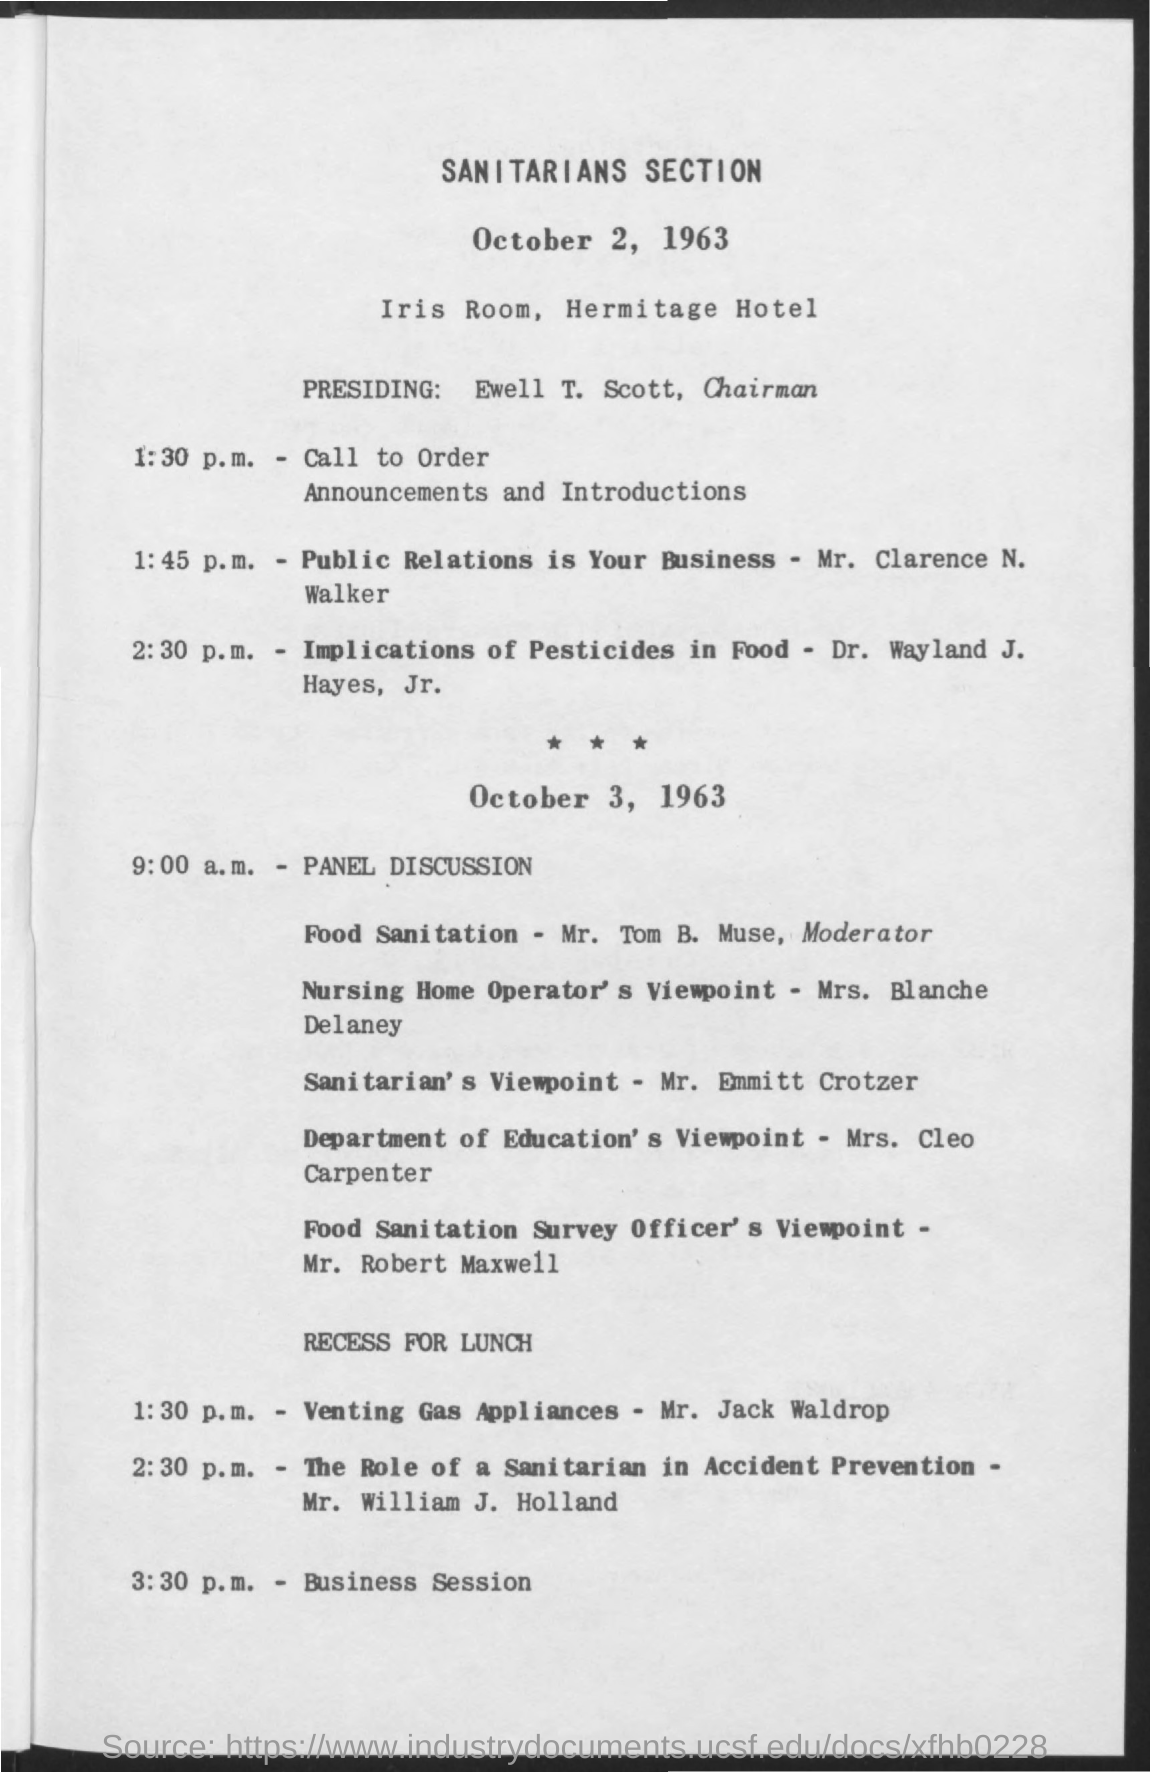Outline some significant characteristics in this image. The chairman's name is Ewell T. Scott. The time for the panel discussion is 9:00 a.m. The time mentioned for the business session is 3:30 p.m. The title mentioned in the bold letters is 'SANITARIANS SECTION. The name of the hotel mentioned is the Hermitage Hotel. 